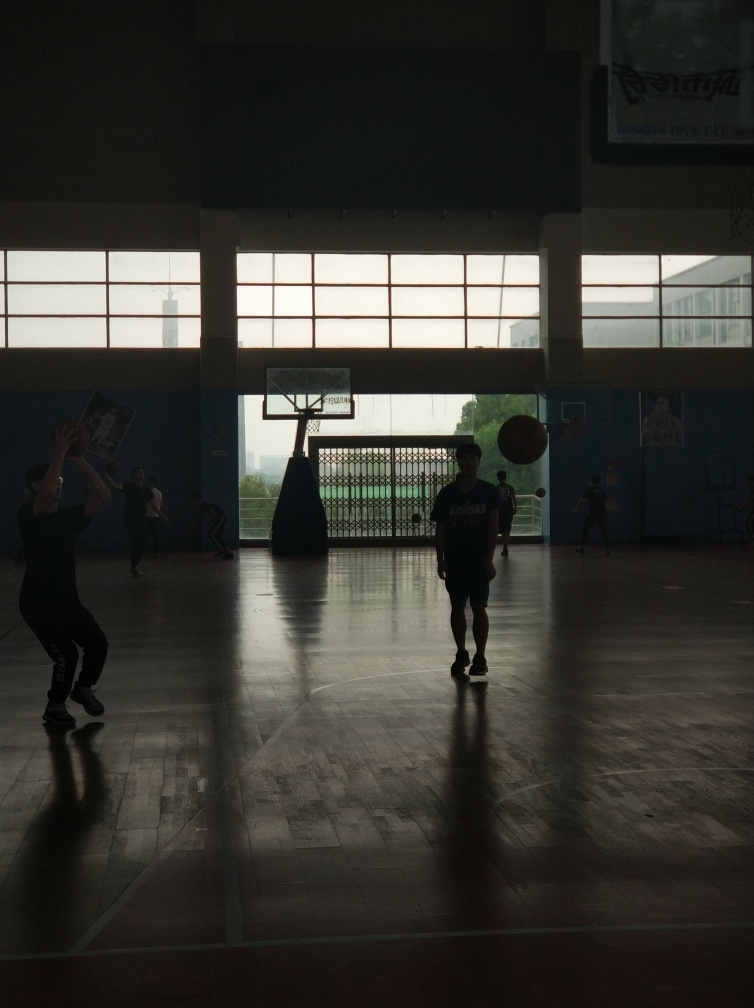Are there any texture details lost due to exposure issues? Yes, some texture details are lost in areas due to the backlighting from the windows, causing a silhouette effect on the subjects and a lack of visible detail in specific parts like the facial features and clothing textures. 